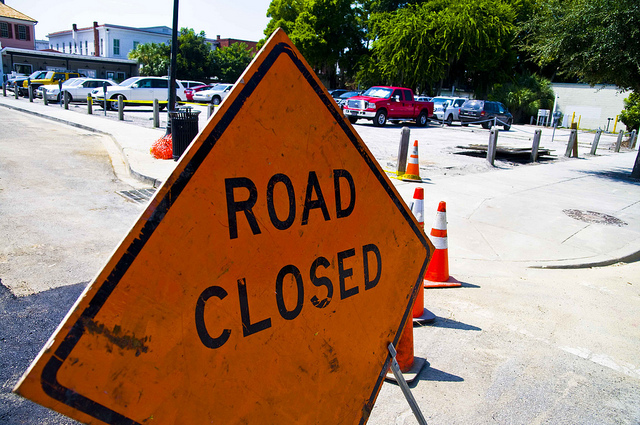Please extract the text content from this image. ROAD CLOSED 